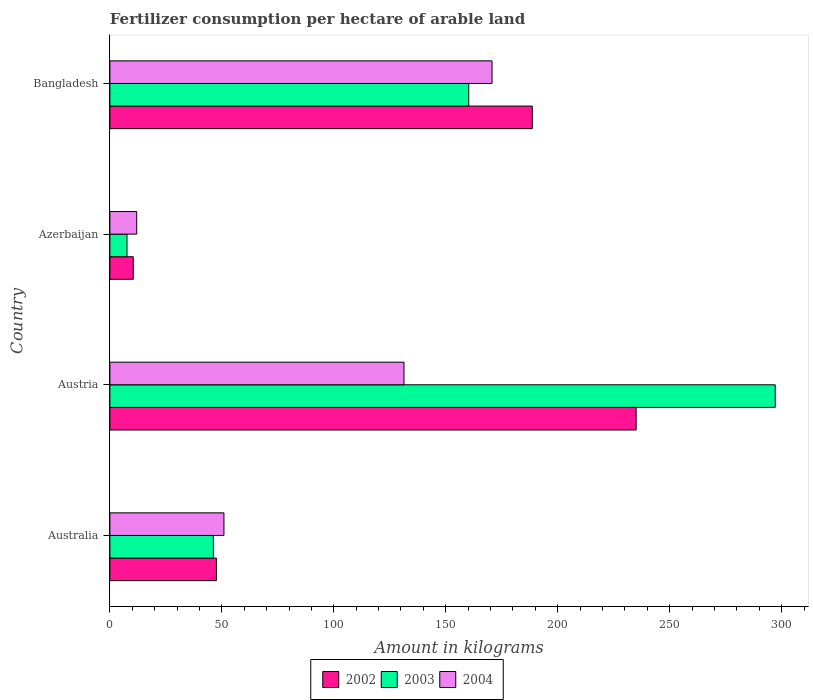How many bars are there on the 2nd tick from the top?
Your response must be concise. 3. How many bars are there on the 3rd tick from the bottom?
Your response must be concise. 3. In how many cases, is the number of bars for a given country not equal to the number of legend labels?
Provide a short and direct response. 0. What is the amount of fertilizer consumption in 2002 in Australia?
Keep it short and to the point. 47.57. Across all countries, what is the maximum amount of fertilizer consumption in 2003?
Offer a very short reply. 297.14. Across all countries, what is the minimum amount of fertilizer consumption in 2004?
Keep it short and to the point. 11.97. In which country was the amount of fertilizer consumption in 2004 maximum?
Make the answer very short. Bangladesh. In which country was the amount of fertilizer consumption in 2002 minimum?
Provide a short and direct response. Azerbaijan. What is the total amount of fertilizer consumption in 2004 in the graph?
Give a very brief answer. 364.94. What is the difference between the amount of fertilizer consumption in 2003 in Azerbaijan and that in Bangladesh?
Provide a succinct answer. -152.62. What is the difference between the amount of fertilizer consumption in 2004 in Austria and the amount of fertilizer consumption in 2002 in Australia?
Offer a terse response. 83.78. What is the average amount of fertilizer consumption in 2003 per country?
Give a very brief answer. 127.81. What is the difference between the amount of fertilizer consumption in 2004 and amount of fertilizer consumption in 2003 in Australia?
Your answer should be very brief. 4.73. In how many countries, is the amount of fertilizer consumption in 2002 greater than 280 kg?
Your response must be concise. 0. What is the ratio of the amount of fertilizer consumption in 2004 in Austria to that in Bangladesh?
Your answer should be compact. 0.77. Is the amount of fertilizer consumption in 2004 in Austria less than that in Bangladesh?
Make the answer very short. Yes. Is the difference between the amount of fertilizer consumption in 2004 in Australia and Austria greater than the difference between the amount of fertilizer consumption in 2003 in Australia and Austria?
Ensure brevity in your answer.  Yes. What is the difference between the highest and the second highest amount of fertilizer consumption in 2004?
Give a very brief answer. 39.32. What is the difference between the highest and the lowest amount of fertilizer consumption in 2004?
Provide a short and direct response. 158.7. What does the 1st bar from the bottom in Bangladesh represents?
Offer a terse response. 2002. How many countries are there in the graph?
Your answer should be compact. 4. Does the graph contain grids?
Ensure brevity in your answer.  No. How many legend labels are there?
Provide a succinct answer. 3. What is the title of the graph?
Offer a very short reply. Fertilizer consumption per hectare of arable land. Does "2014" appear as one of the legend labels in the graph?
Give a very brief answer. No. What is the label or title of the X-axis?
Offer a very short reply. Amount in kilograms. What is the label or title of the Y-axis?
Provide a short and direct response. Country. What is the Amount in kilograms in 2002 in Australia?
Give a very brief answer. 47.57. What is the Amount in kilograms of 2003 in Australia?
Ensure brevity in your answer.  46.21. What is the Amount in kilograms of 2004 in Australia?
Provide a succinct answer. 50.94. What is the Amount in kilograms in 2002 in Austria?
Your answer should be compact. 235.03. What is the Amount in kilograms of 2003 in Austria?
Provide a short and direct response. 297.14. What is the Amount in kilograms in 2004 in Austria?
Provide a succinct answer. 131.35. What is the Amount in kilograms of 2002 in Azerbaijan?
Give a very brief answer. 10.43. What is the Amount in kilograms in 2003 in Azerbaijan?
Offer a terse response. 7.64. What is the Amount in kilograms in 2004 in Azerbaijan?
Provide a short and direct response. 11.97. What is the Amount in kilograms in 2002 in Bangladesh?
Offer a very short reply. 188.64. What is the Amount in kilograms in 2003 in Bangladesh?
Give a very brief answer. 160.27. What is the Amount in kilograms of 2004 in Bangladesh?
Your answer should be compact. 170.67. Across all countries, what is the maximum Amount in kilograms in 2002?
Ensure brevity in your answer.  235.03. Across all countries, what is the maximum Amount in kilograms in 2003?
Your answer should be compact. 297.14. Across all countries, what is the maximum Amount in kilograms in 2004?
Ensure brevity in your answer.  170.67. Across all countries, what is the minimum Amount in kilograms of 2002?
Give a very brief answer. 10.43. Across all countries, what is the minimum Amount in kilograms in 2003?
Provide a succinct answer. 7.64. Across all countries, what is the minimum Amount in kilograms in 2004?
Keep it short and to the point. 11.97. What is the total Amount in kilograms of 2002 in the graph?
Your answer should be compact. 481.67. What is the total Amount in kilograms in 2003 in the graph?
Provide a succinct answer. 511.26. What is the total Amount in kilograms in 2004 in the graph?
Provide a short and direct response. 364.94. What is the difference between the Amount in kilograms of 2002 in Australia and that in Austria?
Your response must be concise. -187.46. What is the difference between the Amount in kilograms in 2003 in Australia and that in Austria?
Offer a terse response. -250.93. What is the difference between the Amount in kilograms in 2004 in Australia and that in Austria?
Offer a terse response. -80.41. What is the difference between the Amount in kilograms in 2002 in Australia and that in Azerbaijan?
Offer a terse response. 37.14. What is the difference between the Amount in kilograms of 2003 in Australia and that in Azerbaijan?
Make the answer very short. 38.57. What is the difference between the Amount in kilograms of 2004 in Australia and that in Azerbaijan?
Keep it short and to the point. 38.96. What is the difference between the Amount in kilograms of 2002 in Australia and that in Bangladesh?
Offer a terse response. -141.07. What is the difference between the Amount in kilograms of 2003 in Australia and that in Bangladesh?
Your response must be concise. -114.06. What is the difference between the Amount in kilograms of 2004 in Australia and that in Bangladesh?
Offer a very short reply. -119.73. What is the difference between the Amount in kilograms in 2002 in Austria and that in Azerbaijan?
Keep it short and to the point. 224.59. What is the difference between the Amount in kilograms of 2003 in Austria and that in Azerbaijan?
Make the answer very short. 289.5. What is the difference between the Amount in kilograms in 2004 in Austria and that in Azerbaijan?
Offer a terse response. 119.38. What is the difference between the Amount in kilograms of 2002 in Austria and that in Bangladesh?
Your response must be concise. 46.39. What is the difference between the Amount in kilograms of 2003 in Austria and that in Bangladesh?
Your response must be concise. 136.87. What is the difference between the Amount in kilograms of 2004 in Austria and that in Bangladesh?
Provide a short and direct response. -39.32. What is the difference between the Amount in kilograms of 2002 in Azerbaijan and that in Bangladesh?
Make the answer very short. -178.21. What is the difference between the Amount in kilograms in 2003 in Azerbaijan and that in Bangladesh?
Provide a succinct answer. -152.62. What is the difference between the Amount in kilograms of 2004 in Azerbaijan and that in Bangladesh?
Give a very brief answer. -158.7. What is the difference between the Amount in kilograms of 2002 in Australia and the Amount in kilograms of 2003 in Austria?
Give a very brief answer. -249.57. What is the difference between the Amount in kilograms of 2002 in Australia and the Amount in kilograms of 2004 in Austria?
Make the answer very short. -83.78. What is the difference between the Amount in kilograms in 2003 in Australia and the Amount in kilograms in 2004 in Austria?
Ensure brevity in your answer.  -85.14. What is the difference between the Amount in kilograms in 2002 in Australia and the Amount in kilograms in 2003 in Azerbaijan?
Your response must be concise. 39.93. What is the difference between the Amount in kilograms in 2002 in Australia and the Amount in kilograms in 2004 in Azerbaijan?
Make the answer very short. 35.6. What is the difference between the Amount in kilograms of 2003 in Australia and the Amount in kilograms of 2004 in Azerbaijan?
Your answer should be very brief. 34.23. What is the difference between the Amount in kilograms in 2002 in Australia and the Amount in kilograms in 2003 in Bangladesh?
Your answer should be very brief. -112.7. What is the difference between the Amount in kilograms of 2002 in Australia and the Amount in kilograms of 2004 in Bangladesh?
Provide a short and direct response. -123.1. What is the difference between the Amount in kilograms in 2003 in Australia and the Amount in kilograms in 2004 in Bangladesh?
Your response must be concise. -124.46. What is the difference between the Amount in kilograms of 2002 in Austria and the Amount in kilograms of 2003 in Azerbaijan?
Offer a very short reply. 227.38. What is the difference between the Amount in kilograms of 2002 in Austria and the Amount in kilograms of 2004 in Azerbaijan?
Your answer should be very brief. 223.05. What is the difference between the Amount in kilograms in 2003 in Austria and the Amount in kilograms in 2004 in Azerbaijan?
Make the answer very short. 285.16. What is the difference between the Amount in kilograms in 2002 in Austria and the Amount in kilograms in 2003 in Bangladesh?
Offer a terse response. 74.76. What is the difference between the Amount in kilograms of 2002 in Austria and the Amount in kilograms of 2004 in Bangladesh?
Your answer should be very brief. 64.35. What is the difference between the Amount in kilograms in 2003 in Austria and the Amount in kilograms in 2004 in Bangladesh?
Your answer should be compact. 126.47. What is the difference between the Amount in kilograms in 2002 in Azerbaijan and the Amount in kilograms in 2003 in Bangladesh?
Give a very brief answer. -149.83. What is the difference between the Amount in kilograms of 2002 in Azerbaijan and the Amount in kilograms of 2004 in Bangladesh?
Ensure brevity in your answer.  -160.24. What is the difference between the Amount in kilograms in 2003 in Azerbaijan and the Amount in kilograms in 2004 in Bangladesh?
Offer a terse response. -163.03. What is the average Amount in kilograms of 2002 per country?
Your answer should be very brief. 120.42. What is the average Amount in kilograms in 2003 per country?
Your answer should be very brief. 127.81. What is the average Amount in kilograms in 2004 per country?
Ensure brevity in your answer.  91.23. What is the difference between the Amount in kilograms in 2002 and Amount in kilograms in 2003 in Australia?
Offer a terse response. 1.36. What is the difference between the Amount in kilograms in 2002 and Amount in kilograms in 2004 in Australia?
Keep it short and to the point. -3.37. What is the difference between the Amount in kilograms of 2003 and Amount in kilograms of 2004 in Australia?
Offer a very short reply. -4.73. What is the difference between the Amount in kilograms in 2002 and Amount in kilograms in 2003 in Austria?
Provide a succinct answer. -62.11. What is the difference between the Amount in kilograms in 2002 and Amount in kilograms in 2004 in Austria?
Offer a very short reply. 103.67. What is the difference between the Amount in kilograms in 2003 and Amount in kilograms in 2004 in Austria?
Make the answer very short. 165.79. What is the difference between the Amount in kilograms of 2002 and Amount in kilograms of 2003 in Azerbaijan?
Your response must be concise. 2.79. What is the difference between the Amount in kilograms of 2002 and Amount in kilograms of 2004 in Azerbaijan?
Your answer should be very brief. -1.54. What is the difference between the Amount in kilograms in 2003 and Amount in kilograms in 2004 in Azerbaijan?
Make the answer very short. -4.33. What is the difference between the Amount in kilograms of 2002 and Amount in kilograms of 2003 in Bangladesh?
Your answer should be very brief. 28.37. What is the difference between the Amount in kilograms of 2002 and Amount in kilograms of 2004 in Bangladesh?
Provide a succinct answer. 17.97. What is the difference between the Amount in kilograms in 2003 and Amount in kilograms in 2004 in Bangladesh?
Offer a very short reply. -10.4. What is the ratio of the Amount in kilograms of 2002 in Australia to that in Austria?
Your response must be concise. 0.2. What is the ratio of the Amount in kilograms of 2003 in Australia to that in Austria?
Your answer should be very brief. 0.16. What is the ratio of the Amount in kilograms of 2004 in Australia to that in Austria?
Provide a succinct answer. 0.39. What is the ratio of the Amount in kilograms of 2002 in Australia to that in Azerbaijan?
Make the answer very short. 4.56. What is the ratio of the Amount in kilograms of 2003 in Australia to that in Azerbaijan?
Offer a very short reply. 6.05. What is the ratio of the Amount in kilograms of 2004 in Australia to that in Azerbaijan?
Keep it short and to the point. 4.25. What is the ratio of the Amount in kilograms of 2002 in Australia to that in Bangladesh?
Keep it short and to the point. 0.25. What is the ratio of the Amount in kilograms of 2003 in Australia to that in Bangladesh?
Offer a terse response. 0.29. What is the ratio of the Amount in kilograms in 2004 in Australia to that in Bangladesh?
Your response must be concise. 0.3. What is the ratio of the Amount in kilograms of 2002 in Austria to that in Azerbaijan?
Give a very brief answer. 22.53. What is the ratio of the Amount in kilograms of 2003 in Austria to that in Azerbaijan?
Your answer should be very brief. 38.88. What is the ratio of the Amount in kilograms of 2004 in Austria to that in Azerbaijan?
Your answer should be very brief. 10.97. What is the ratio of the Amount in kilograms of 2002 in Austria to that in Bangladesh?
Your response must be concise. 1.25. What is the ratio of the Amount in kilograms of 2003 in Austria to that in Bangladesh?
Your answer should be compact. 1.85. What is the ratio of the Amount in kilograms in 2004 in Austria to that in Bangladesh?
Your answer should be compact. 0.77. What is the ratio of the Amount in kilograms in 2002 in Azerbaijan to that in Bangladesh?
Provide a succinct answer. 0.06. What is the ratio of the Amount in kilograms of 2003 in Azerbaijan to that in Bangladesh?
Provide a succinct answer. 0.05. What is the ratio of the Amount in kilograms of 2004 in Azerbaijan to that in Bangladesh?
Keep it short and to the point. 0.07. What is the difference between the highest and the second highest Amount in kilograms of 2002?
Your answer should be very brief. 46.39. What is the difference between the highest and the second highest Amount in kilograms in 2003?
Ensure brevity in your answer.  136.87. What is the difference between the highest and the second highest Amount in kilograms of 2004?
Provide a succinct answer. 39.32. What is the difference between the highest and the lowest Amount in kilograms in 2002?
Make the answer very short. 224.59. What is the difference between the highest and the lowest Amount in kilograms of 2003?
Your answer should be compact. 289.5. What is the difference between the highest and the lowest Amount in kilograms in 2004?
Make the answer very short. 158.7. 